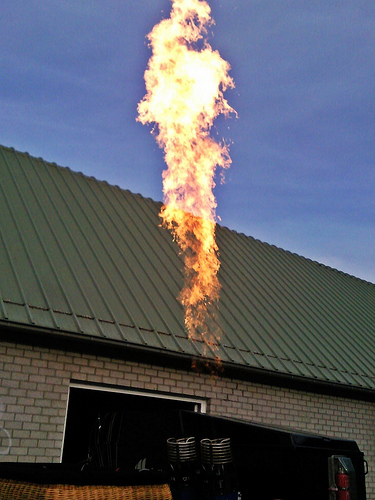<image>
Is the fire on the house? Yes. Looking at the image, I can see the fire is positioned on top of the house, with the house providing support. 